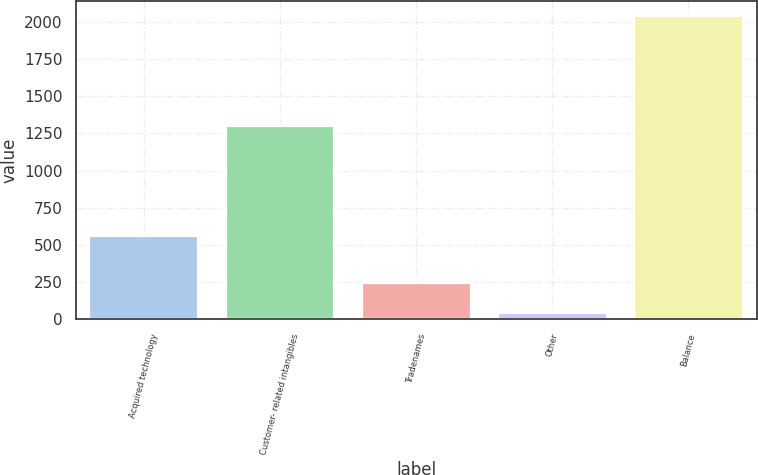<chart> <loc_0><loc_0><loc_500><loc_500><bar_chart><fcel>Acquired technology<fcel>Customer- related intangibles<fcel>Tradenames<fcel>Other<fcel>Balance<nl><fcel>560<fcel>1302<fcel>241.6<fcel>42<fcel>2038<nl></chart> 